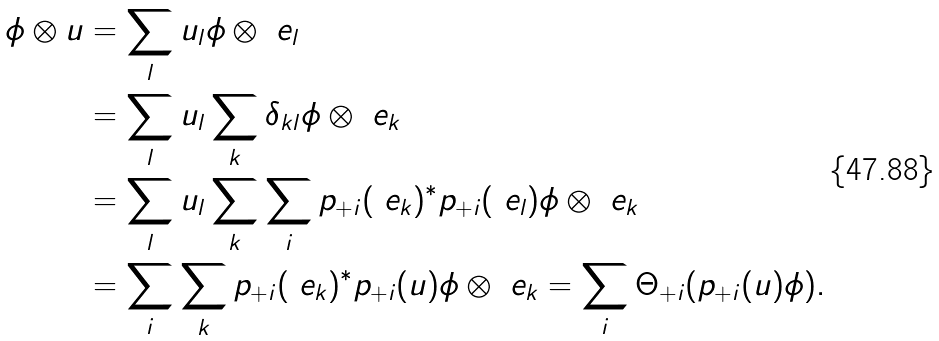Convert formula to latex. <formula><loc_0><loc_0><loc_500><loc_500>\phi \otimes u & = \sum _ { l } u _ { l } \phi \otimes \ e _ { l } \\ & = \sum _ { l } u _ { l } \sum _ { k } \delta _ { k l } \phi \otimes \ e _ { k } \\ & = \sum _ { l } u _ { l } \sum _ { k } \sum _ { i } p _ { + i } ( \ e _ { k } ) ^ { \ast } p _ { + i } ( \ e _ { l } ) \phi \otimes \ e _ { k } \\ & = \sum _ { i } \sum _ { k } p _ { + i } ( \ e _ { k } ) ^ { \ast } p _ { + i } ( u ) \phi \otimes \ e _ { k } = \sum _ { i } \Theta _ { + i } ( p _ { + i } ( u ) \phi ) .</formula> 